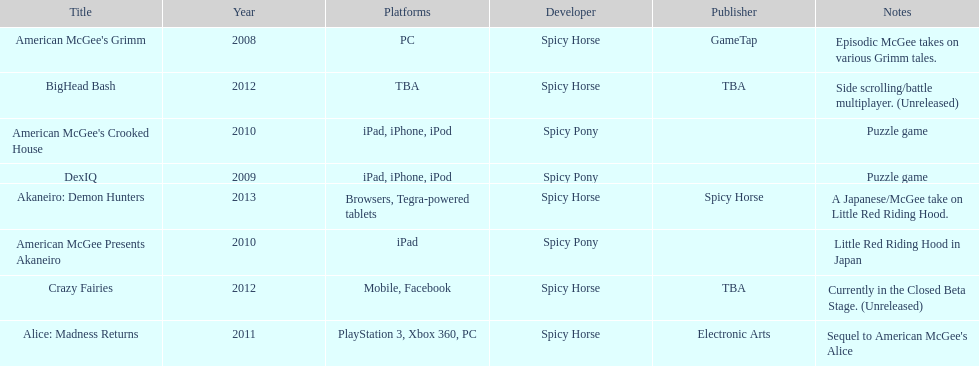How many platforms did american mcgee's grimm run on? 1. 